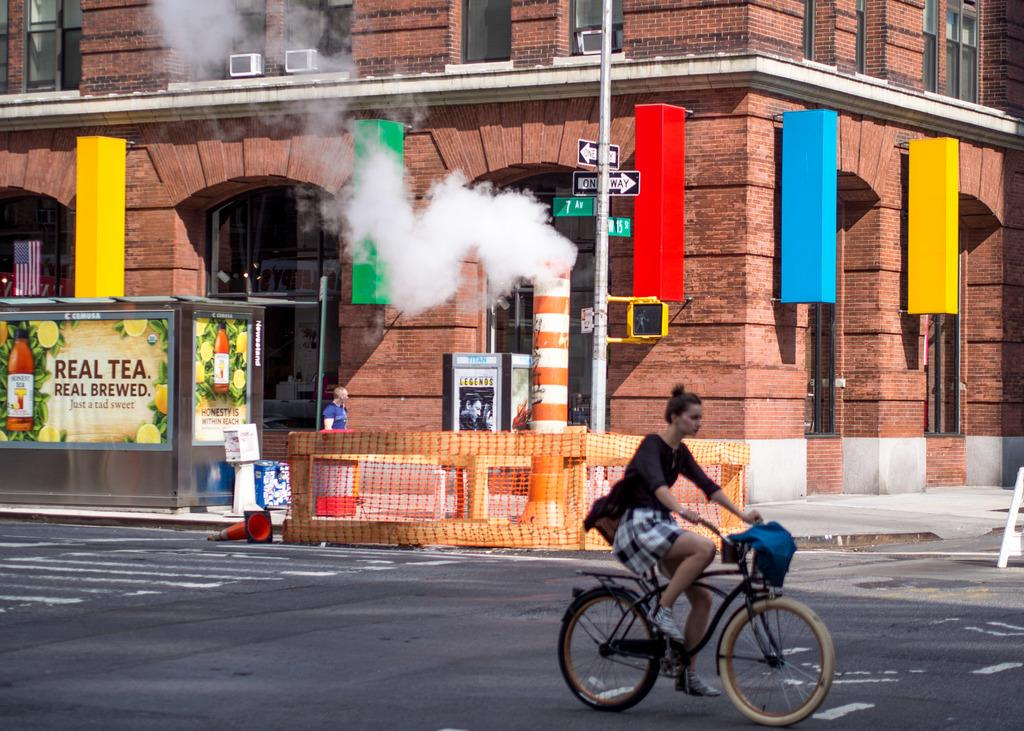What structure is present in the image? There is a building in the image. What can be seen coming from the building in the image? There is smoke visible in the image. What activity is the girl in the image engaged in? There is a girl riding a bicycle in the image. What type of lamp is hanging from the building in the image? There is no lamp present in the image. What year is depicted in the image? The image does not depict a specific year. What type of society is shown in the image? The image does not depict a specific society. 